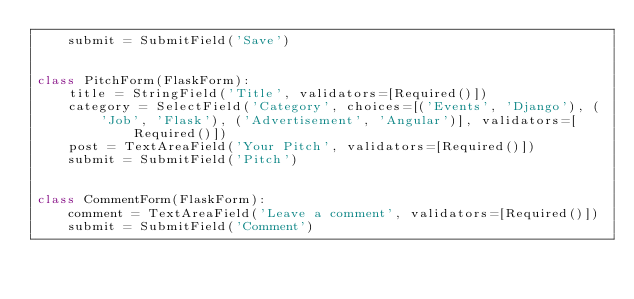<code> <loc_0><loc_0><loc_500><loc_500><_Python_>    submit = SubmitField('Save')


class PitchForm(FlaskForm):
    title = StringField('Title', validators=[Required()])
    category = SelectField('Category', choices=[('Events', 'Django'), (
        'Job', 'Flask'), ('Advertisement', 'Angular')], validators=[Required()])
    post = TextAreaField('Your Pitch', validators=[Required()])
    submit = SubmitField('Pitch')


class CommentForm(FlaskForm):
    comment = TextAreaField('Leave a comment', validators=[Required()])
    submit = SubmitField('Comment')
</code> 